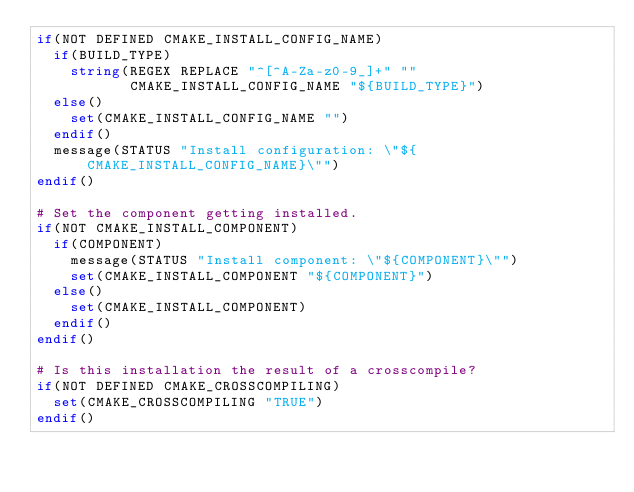<code> <loc_0><loc_0><loc_500><loc_500><_CMake_>if(NOT DEFINED CMAKE_INSTALL_CONFIG_NAME)
  if(BUILD_TYPE)
    string(REGEX REPLACE "^[^A-Za-z0-9_]+" ""
           CMAKE_INSTALL_CONFIG_NAME "${BUILD_TYPE}")
  else()
    set(CMAKE_INSTALL_CONFIG_NAME "")
  endif()
  message(STATUS "Install configuration: \"${CMAKE_INSTALL_CONFIG_NAME}\"")
endif()

# Set the component getting installed.
if(NOT CMAKE_INSTALL_COMPONENT)
  if(COMPONENT)
    message(STATUS "Install component: \"${COMPONENT}\"")
    set(CMAKE_INSTALL_COMPONENT "${COMPONENT}")
  else()
    set(CMAKE_INSTALL_COMPONENT)
  endif()
endif()

# Is this installation the result of a crosscompile?
if(NOT DEFINED CMAKE_CROSSCOMPILING)
  set(CMAKE_CROSSCOMPILING "TRUE")
endif()

</code> 